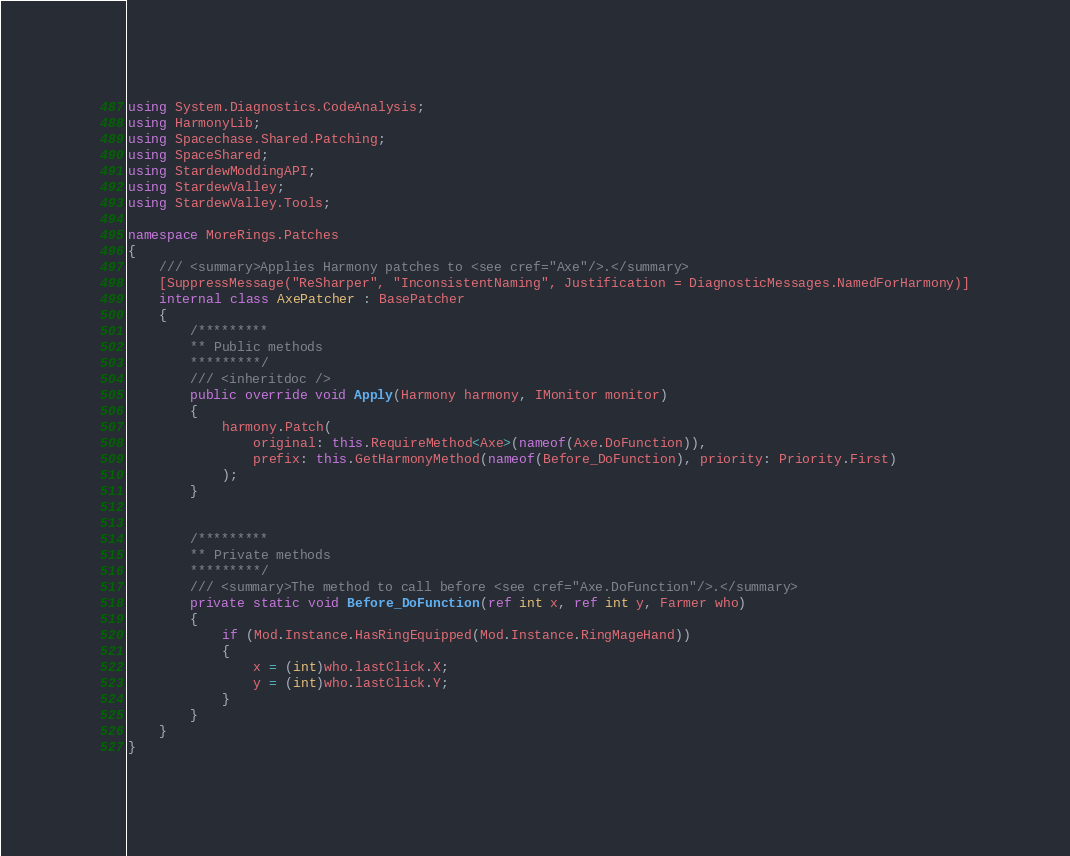Convert code to text. <code><loc_0><loc_0><loc_500><loc_500><_C#_>using System.Diagnostics.CodeAnalysis;
using HarmonyLib;
using Spacechase.Shared.Patching;
using SpaceShared;
using StardewModdingAPI;
using StardewValley;
using StardewValley.Tools;

namespace MoreRings.Patches
{
    /// <summary>Applies Harmony patches to <see cref="Axe"/>.</summary>
    [SuppressMessage("ReSharper", "InconsistentNaming", Justification = DiagnosticMessages.NamedForHarmony)]
    internal class AxePatcher : BasePatcher
    {
        /*********
        ** Public methods
        *********/
        /// <inheritdoc />
        public override void Apply(Harmony harmony, IMonitor monitor)
        {
            harmony.Patch(
                original: this.RequireMethod<Axe>(nameof(Axe.DoFunction)),
                prefix: this.GetHarmonyMethod(nameof(Before_DoFunction), priority: Priority.First)
            );
        }


        /*********
        ** Private methods
        *********/
        /// <summary>The method to call before <see cref="Axe.DoFunction"/>.</summary>
        private static void Before_DoFunction(ref int x, ref int y, Farmer who)
        {
            if (Mod.Instance.HasRingEquipped(Mod.Instance.RingMageHand))
            {
                x = (int)who.lastClick.X;
                y = (int)who.lastClick.Y;
            }
        }
    }
}
</code> 